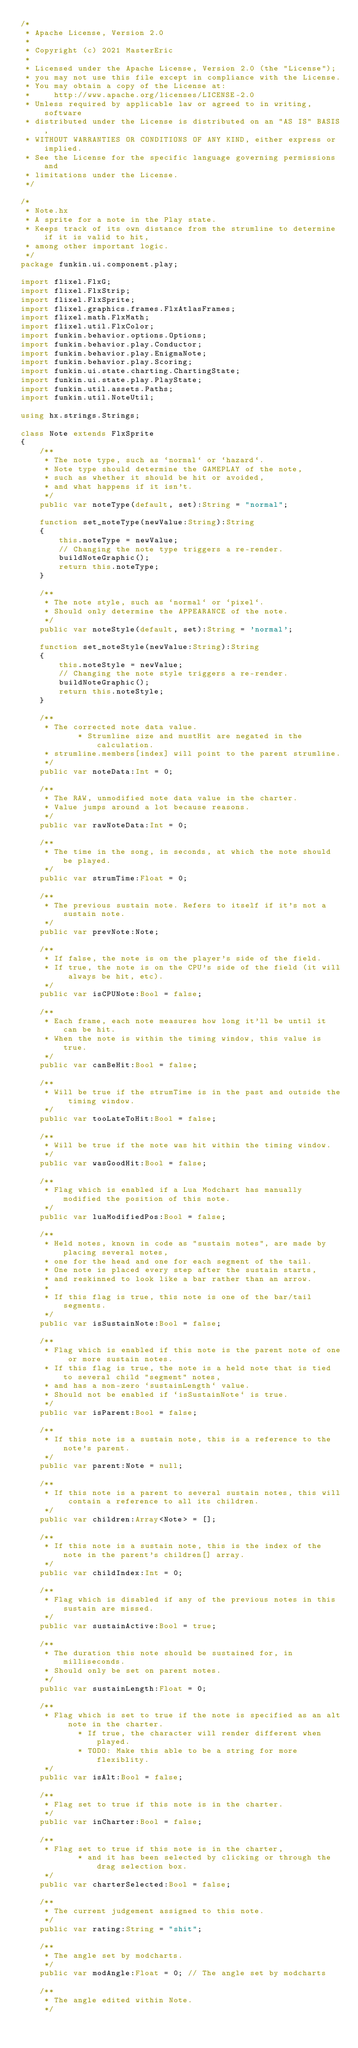Convert code to text. <code><loc_0><loc_0><loc_500><loc_500><_Haxe_>/*
 * Apache License, Version 2.0
 *
 * Copyright (c) 2021 MasterEric
 *
 * Licensed under the Apache License, Version 2.0 (the "License");
 * you may not use this file except in compliance with the License.
 * You may obtain a copy of the License at:
 *     http://www.apache.org/licenses/LICENSE-2.0
 * Unless required by applicable law or agreed to in writing, software
 * distributed under the License is distributed on an "AS IS" BASIS,
 * WITHOUT WARRANTIES OR CONDITIONS OF ANY KIND, either express or implied.
 * See the License for the specific language governing permissions and
 * limitations under the License.
 */

/*
 * Note.hx
 * A sprite for a note in the Play state.
 * Keeps track of its own distance from the strumline to determine if it is valid to hit,
 * among other important logic.
 */
package funkin.ui.component.play;

import flixel.FlxG;
import flixel.FlxStrip;
import flixel.FlxSprite;
import flixel.graphics.frames.FlxAtlasFrames;
import flixel.math.FlxMath;
import flixel.util.FlxColor;
import funkin.behavior.options.Options;
import funkin.behavior.play.Conductor;
import funkin.behavior.play.EnigmaNote;
import funkin.behavior.play.Scoring;
import funkin.ui.state.charting.ChartingState;
import funkin.ui.state.play.PlayState;
import funkin.util.assets.Paths;
import funkin.util.NoteUtil;

using hx.strings.Strings;

class Note extends FlxSprite
{
	/**
	 * The note type, such as `normal` or `hazard`.
	 * Note type should determine the GAMEPLAY of the note,
	 * such as whether it should be hit or avoided,
	 * and what happens if it isn't.
	 */
	public var noteType(default, set):String = "normal";

	function set_noteType(newValue:String):String
	{
		this.noteType = newValue;
		// Changing the note type triggers a re-render.
		buildNoteGraphic();
		return this.noteType;
	}

	/**
	 * The note style, such as `normal` or `pixel`.
	 * Should only determine the APPEARANCE of the note.
	 */
	public var noteStyle(default, set):String = 'normal';

	function set_noteStyle(newValue:String):String
	{
		this.noteStyle = newValue;
		// Changing the note style triggers a re-render.
		buildNoteGraphic();
		return this.noteStyle;
	}

	/**
	 * The corrected note data value.
	 		* Strumline size and mustHit are negated in the calculation.
	 * strumline.members[index] will point to the parent strumline.
	 */
	public var noteData:Int = 0;

	/**
	 * The RAW, unmodified note data value in the charter.
	 * Value jumps around a lot because reasons.
	 */
	public var rawNoteData:Int = 0;

	/**
	 * The time in the song, in seconds, at which the note should be played.
	 */
	public var strumTime:Float = 0;

	/**
	 * The previous sustain note. Refers to itself if it's not a sustain note.
	 */
	public var prevNote:Note;

	/**
	 * If false, the note is on the player's side of the field.
	 * If true, the note is on the CPU's side of the field (it will always be hit, etc).
	 */
	public var isCPUNote:Bool = false;

	/**
	 * Each frame, each note measures how long it'll be until it can be hit.
	 * When the note is within the timing window, this value is true.
	 */
	public var canBeHit:Bool = false;

	/**
	 * Will be true if the strumTime is in the past and outside the timing window.
	 */
	public var tooLateToHit:Bool = false;

	/**
	 * Will be true if the note was hit within the timing window.
	 */
	public var wasGoodHit:Bool = false;

	/**
	 * Flag which is enabled if a Lua Modchart has manually modified the position of this note.
	 */
	public var luaModifiedPos:Bool = false;

	/**
	 * Held notes, known in code as "sustain notes", are made by placing several notes,
	 * one for the head and one for each segment of the tail.
	 * One note is placed every step after the sustain starts,
	 * and reskinned to look like a bar rather than an arrow.
	 * 
	 * If this flag is true, this note is one of the bar/tail segments.
	 */
	public var isSustainNote:Bool = false;

	/**
	 * Flag which is enabled if this note is the parent note of one or more sustain notes.
	 * If this flag is true, the note is a held note that is tied to several child "segment" notes,
	 * and has a non-zero `sustainLength` value.
	 * Should not be enabled if `isSustainNote` is true.
	 */
	public var isParent:Bool = false;

	/**
	 * If this note is a sustain note, this is a reference to the note's parent.
	 */
	public var parent:Note = null;

	/**
	 * If this note is a parent to several sustain notes, this will contain a reference to all its children.
	 */
	public var children:Array<Note> = [];

	/**
	 * If this note is a sustain note, this is the index of the note in the parent's children[] array.
	 */
	public var childIndex:Int = 0;

	/**
	 * Flag which is disabled if any of the previous notes in this sustain are missed.
	 */
	public var sustainActive:Bool = true;

	/**
	 * The duration this note should be sustained for, in milliseconds.
	 * Should only be set on parent notes.
	 */
	public var sustainLength:Float = 0;

	/**
	 * Flag which is set to true if the note is specified as an alt note in the charter.
	 		* If true, the character will render different when played.
	 		* TODO: Make this able to be a string for more flexiblity.
	 */
	public var isAlt:Bool = false;

	/**
	 * Flag set to true if this note is in the charter.
	 */
	public var inCharter:Bool = false;

	/**
	 * Flag set to true if this note is in the charter,
	 		* and it has been selected by clicking or through the drag selection box.
	 */
	public var charterSelected:Bool = false;

	/**
	 * The current judgement assigned to this note.
	 */
	public var rating:String = "shit";

	/**
	 * The angle set by modcharts.
	 */
	public var modAngle:Float = 0; // The angle set by modcharts

	/**
	 * The angle edited within Note.
	 */</code> 